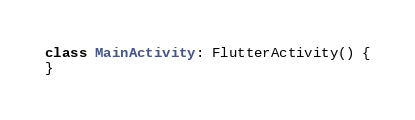Convert code to text. <code><loc_0><loc_0><loc_500><loc_500><_Kotlin_>class MainActivity: FlutterActivity() {
}
</code> 